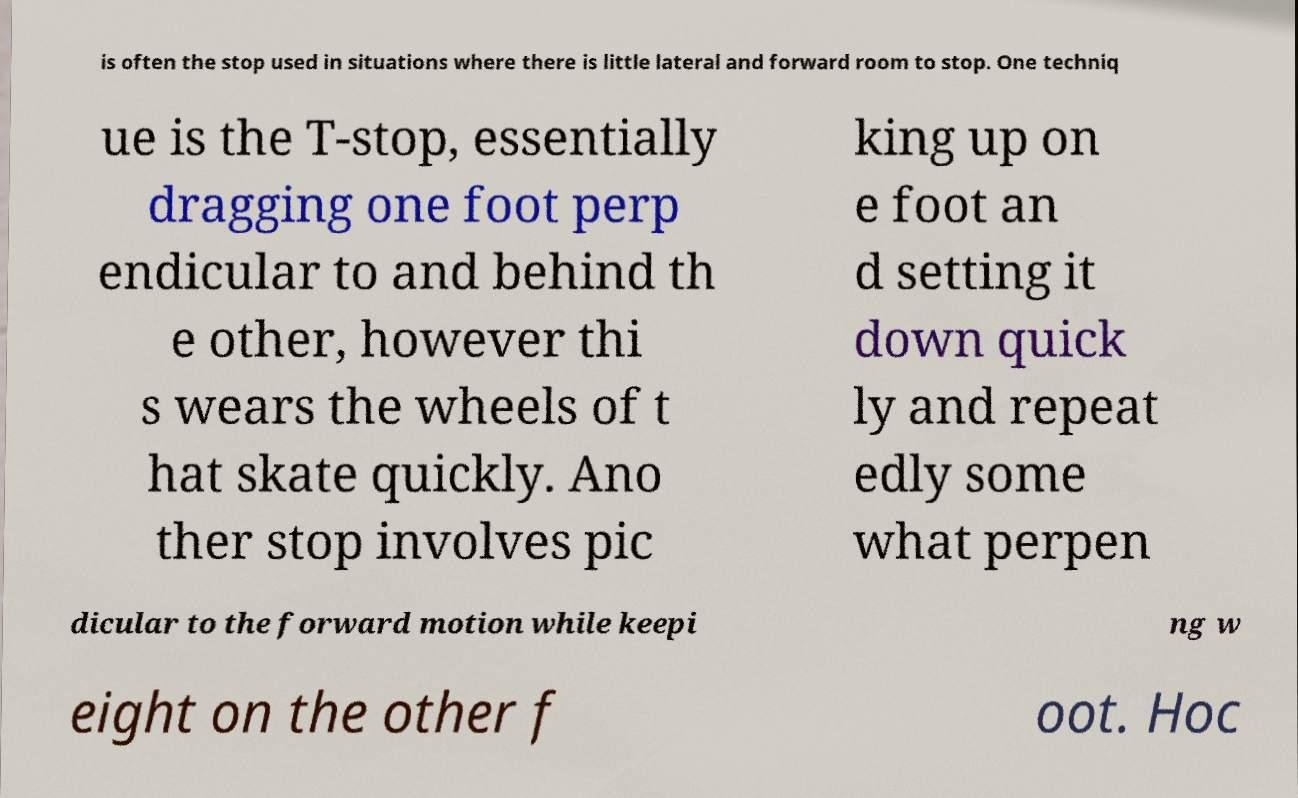For documentation purposes, I need the text within this image transcribed. Could you provide that? is often the stop used in situations where there is little lateral and forward room to stop. One techniq ue is the T-stop, essentially dragging one foot perp endicular to and behind th e other, however thi s wears the wheels of t hat skate quickly. Ano ther stop involves pic king up on e foot an d setting it down quick ly and repeat edly some what perpen dicular to the forward motion while keepi ng w eight on the other f oot. Hoc 